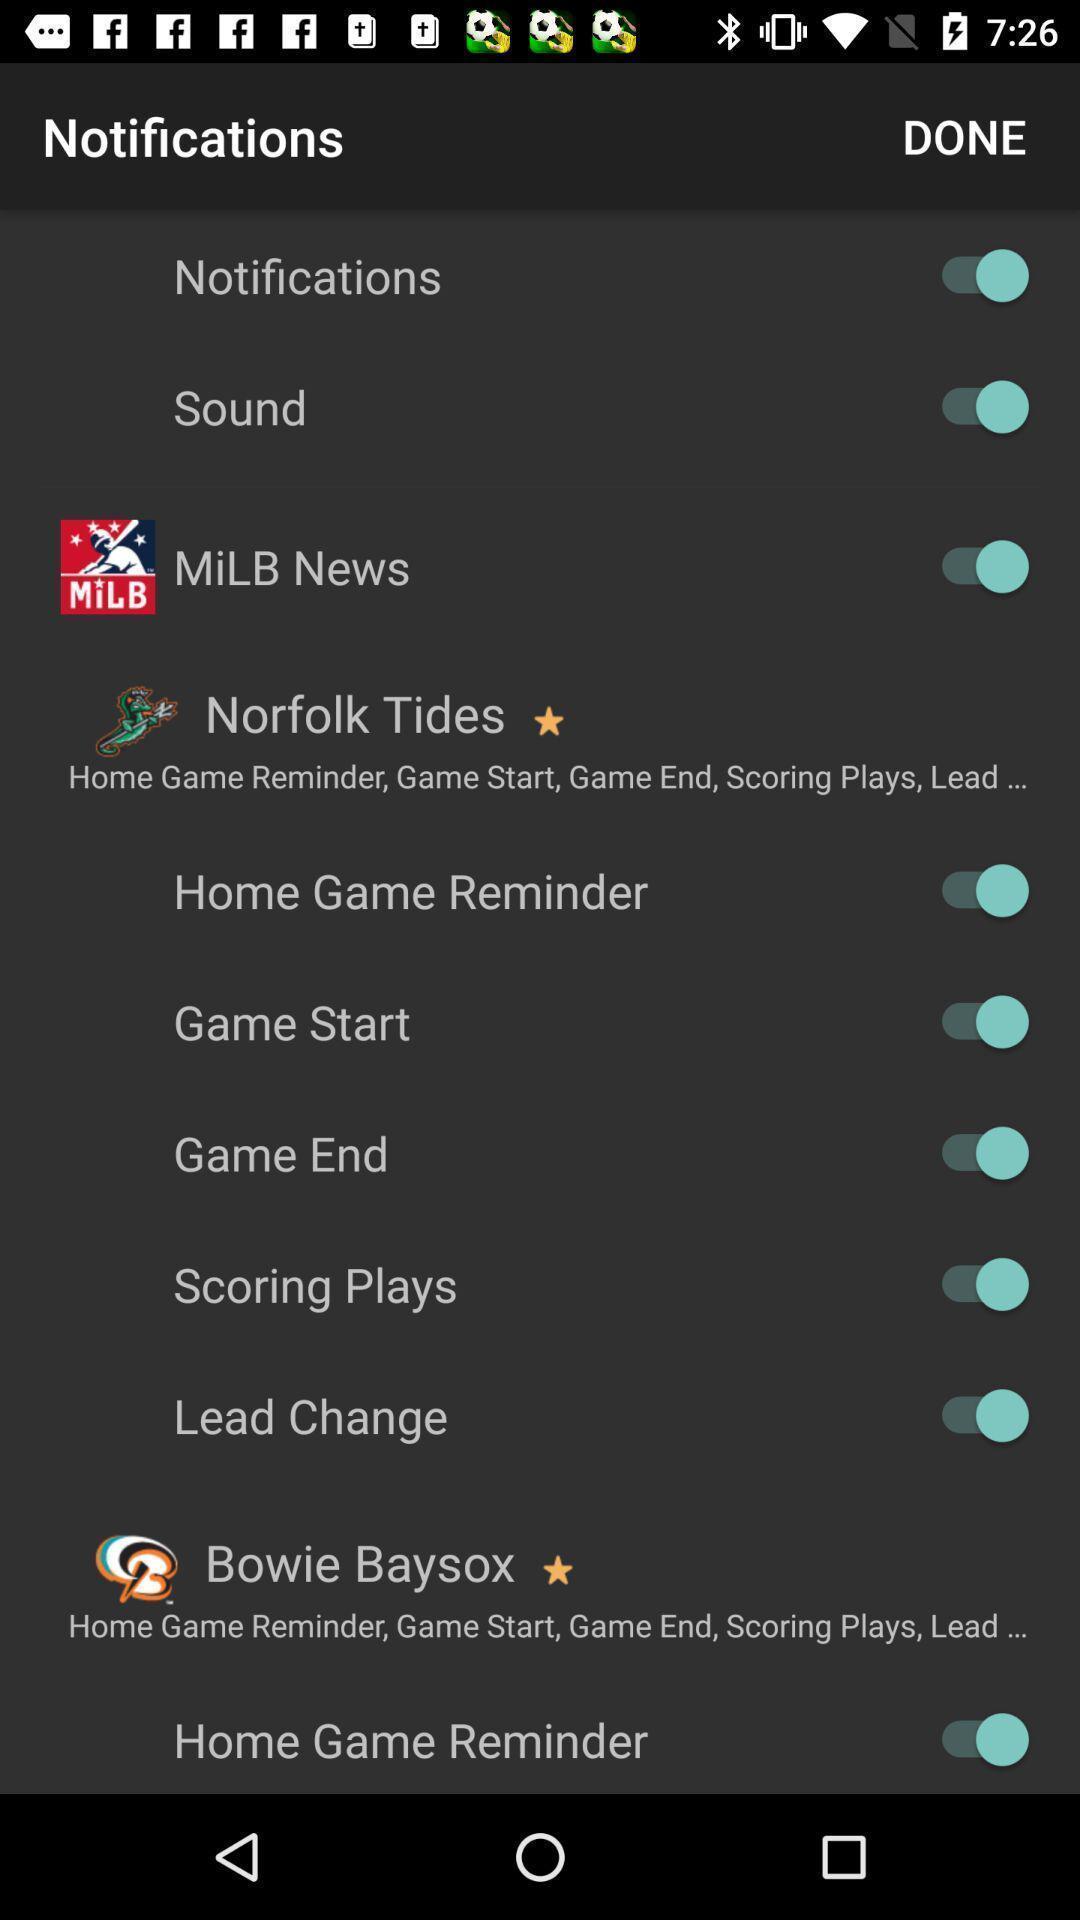Give me a summary of this screen capture. Page showing a variety of notification settings. 